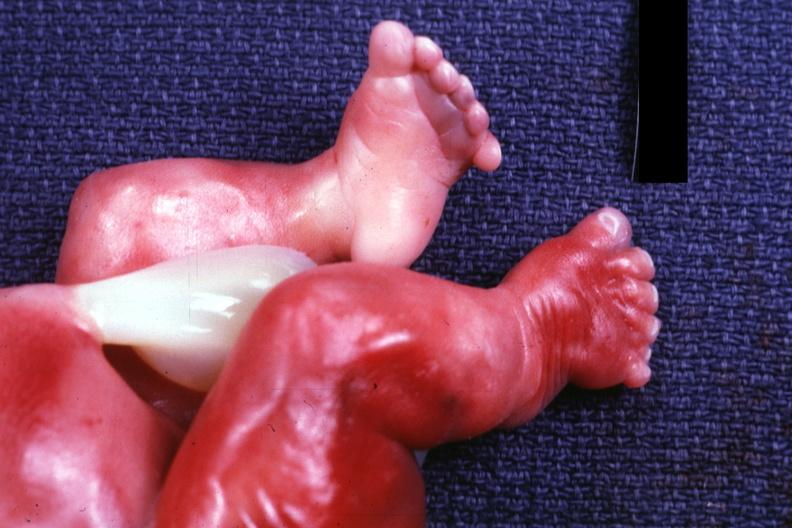what appear clubbed?
Answer the question using a single word or phrase. Feet 